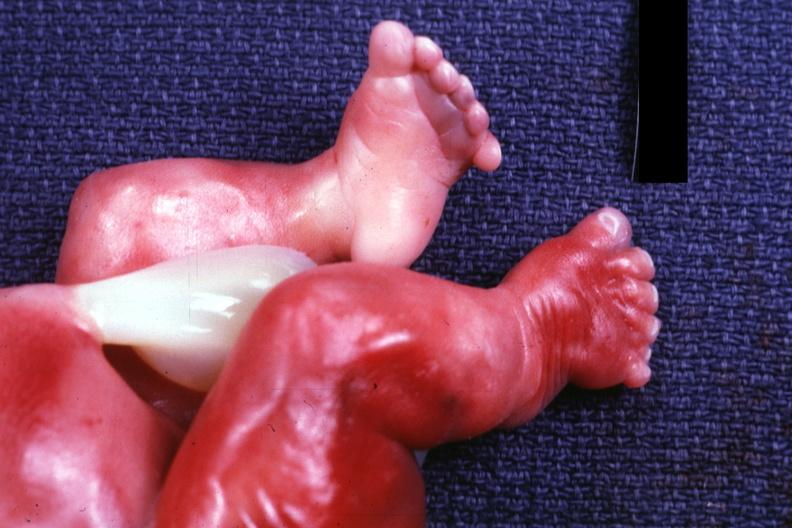what appear clubbed?
Answer the question using a single word or phrase. Feet 